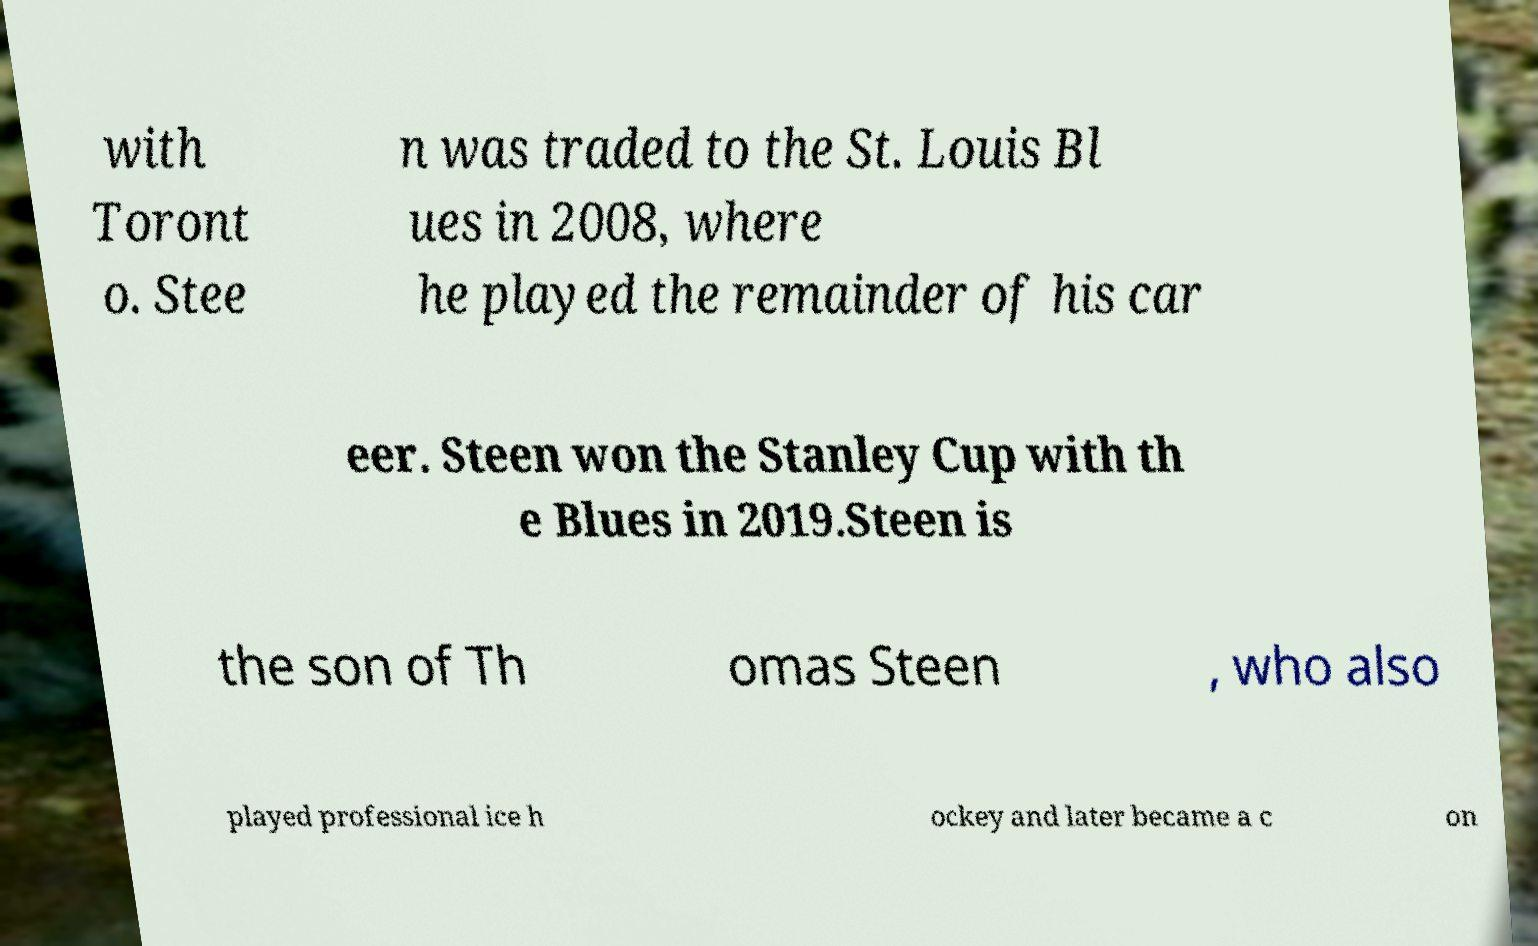Please identify and transcribe the text found in this image. with Toront o. Stee n was traded to the St. Louis Bl ues in 2008, where he played the remainder of his car eer. Steen won the Stanley Cup with th e Blues in 2019.Steen is the son of Th omas Steen , who also played professional ice h ockey and later became a c on 